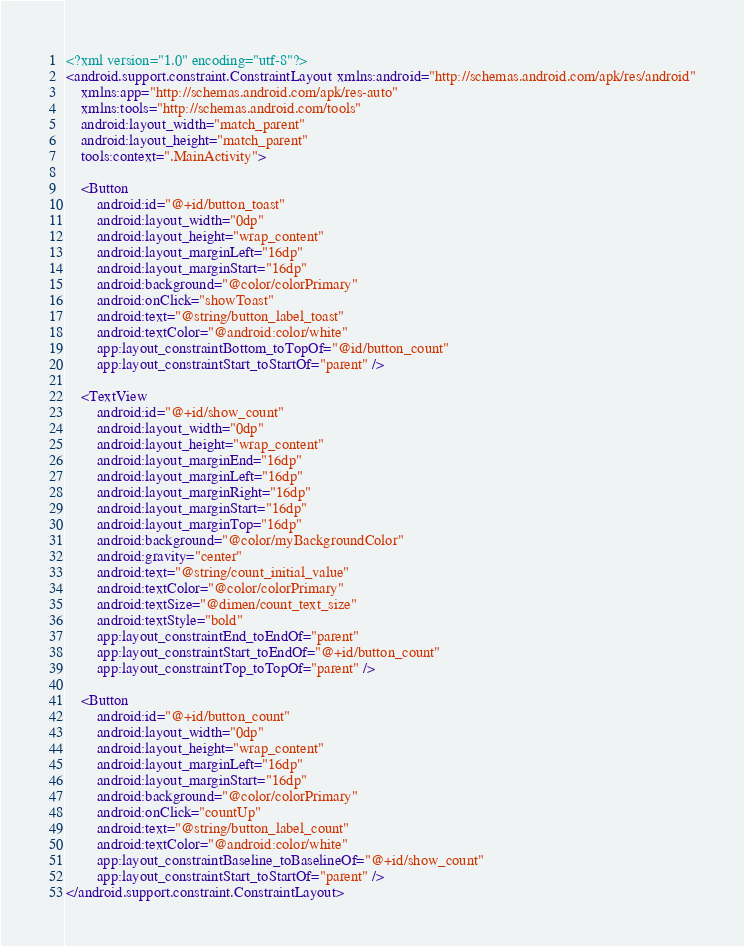<code> <loc_0><loc_0><loc_500><loc_500><_XML_><?xml version="1.0" encoding="utf-8"?>
<android.support.constraint.ConstraintLayout xmlns:android="http://schemas.android.com/apk/res/android"
    xmlns:app="http://schemas.android.com/apk/res-auto"
    xmlns:tools="http://schemas.android.com/tools"
    android:layout_width="match_parent"
    android:layout_height="match_parent"
    tools:context=".MainActivity">

    <Button
        android:id="@+id/button_toast"
        android:layout_width="0dp"
        android:layout_height="wrap_content"
        android:layout_marginLeft="16dp"
        android:layout_marginStart="16dp"
        android:background="@color/colorPrimary"
        android:onClick="showToast"
        android:text="@string/button_label_toast"
        android:textColor="@android:color/white"
        app:layout_constraintBottom_toTopOf="@id/button_count"
        app:layout_constraintStart_toStartOf="parent" />

    <TextView
        android:id="@+id/show_count"
        android:layout_width="0dp"
        android:layout_height="wrap_content"
        android:layout_marginEnd="16dp"
        android:layout_marginLeft="16dp"
        android:layout_marginRight="16dp"
        android:layout_marginStart="16dp"
        android:layout_marginTop="16dp"
        android:background="@color/myBackgroundColor"
        android:gravity="center"
        android:text="@string/count_initial_value"
        android:textColor="@color/colorPrimary"
        android:textSize="@dimen/count_text_size"
        android:textStyle="bold"
        app:layout_constraintEnd_toEndOf="parent"
        app:layout_constraintStart_toEndOf="@+id/button_count"
        app:layout_constraintTop_toTopOf="parent" />

    <Button
        android:id="@+id/button_count"
        android:layout_width="0dp"
        android:layout_height="wrap_content"
        android:layout_marginLeft="16dp"
        android:layout_marginStart="16dp"
        android:background="@color/colorPrimary"
        android:onClick="countUp"
        android:text="@string/button_label_count"
        android:textColor="@android:color/white"
        app:layout_constraintBaseline_toBaselineOf="@+id/show_count"
        app:layout_constraintStart_toStartOf="parent" />
</android.support.constraint.ConstraintLayout></code> 